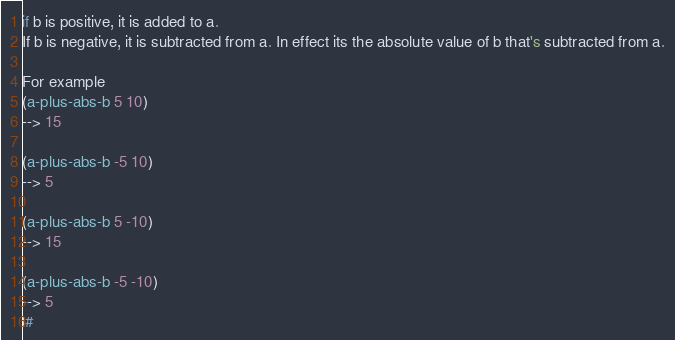<code> <loc_0><loc_0><loc_500><loc_500><_Scheme_>
if b is positive, it is added to a. 
If b is negative, it is subtracted from a. In effect its the absolute value of b that's subtracted from a.

For example
(a-plus-abs-b 5 10)
--> 15

(a-plus-abs-b -5 10)
--> 5

(a-plus-abs-b 5 -10)
--> 15

(a-plus-abs-b -5 -10)
--> 5
|#</code> 